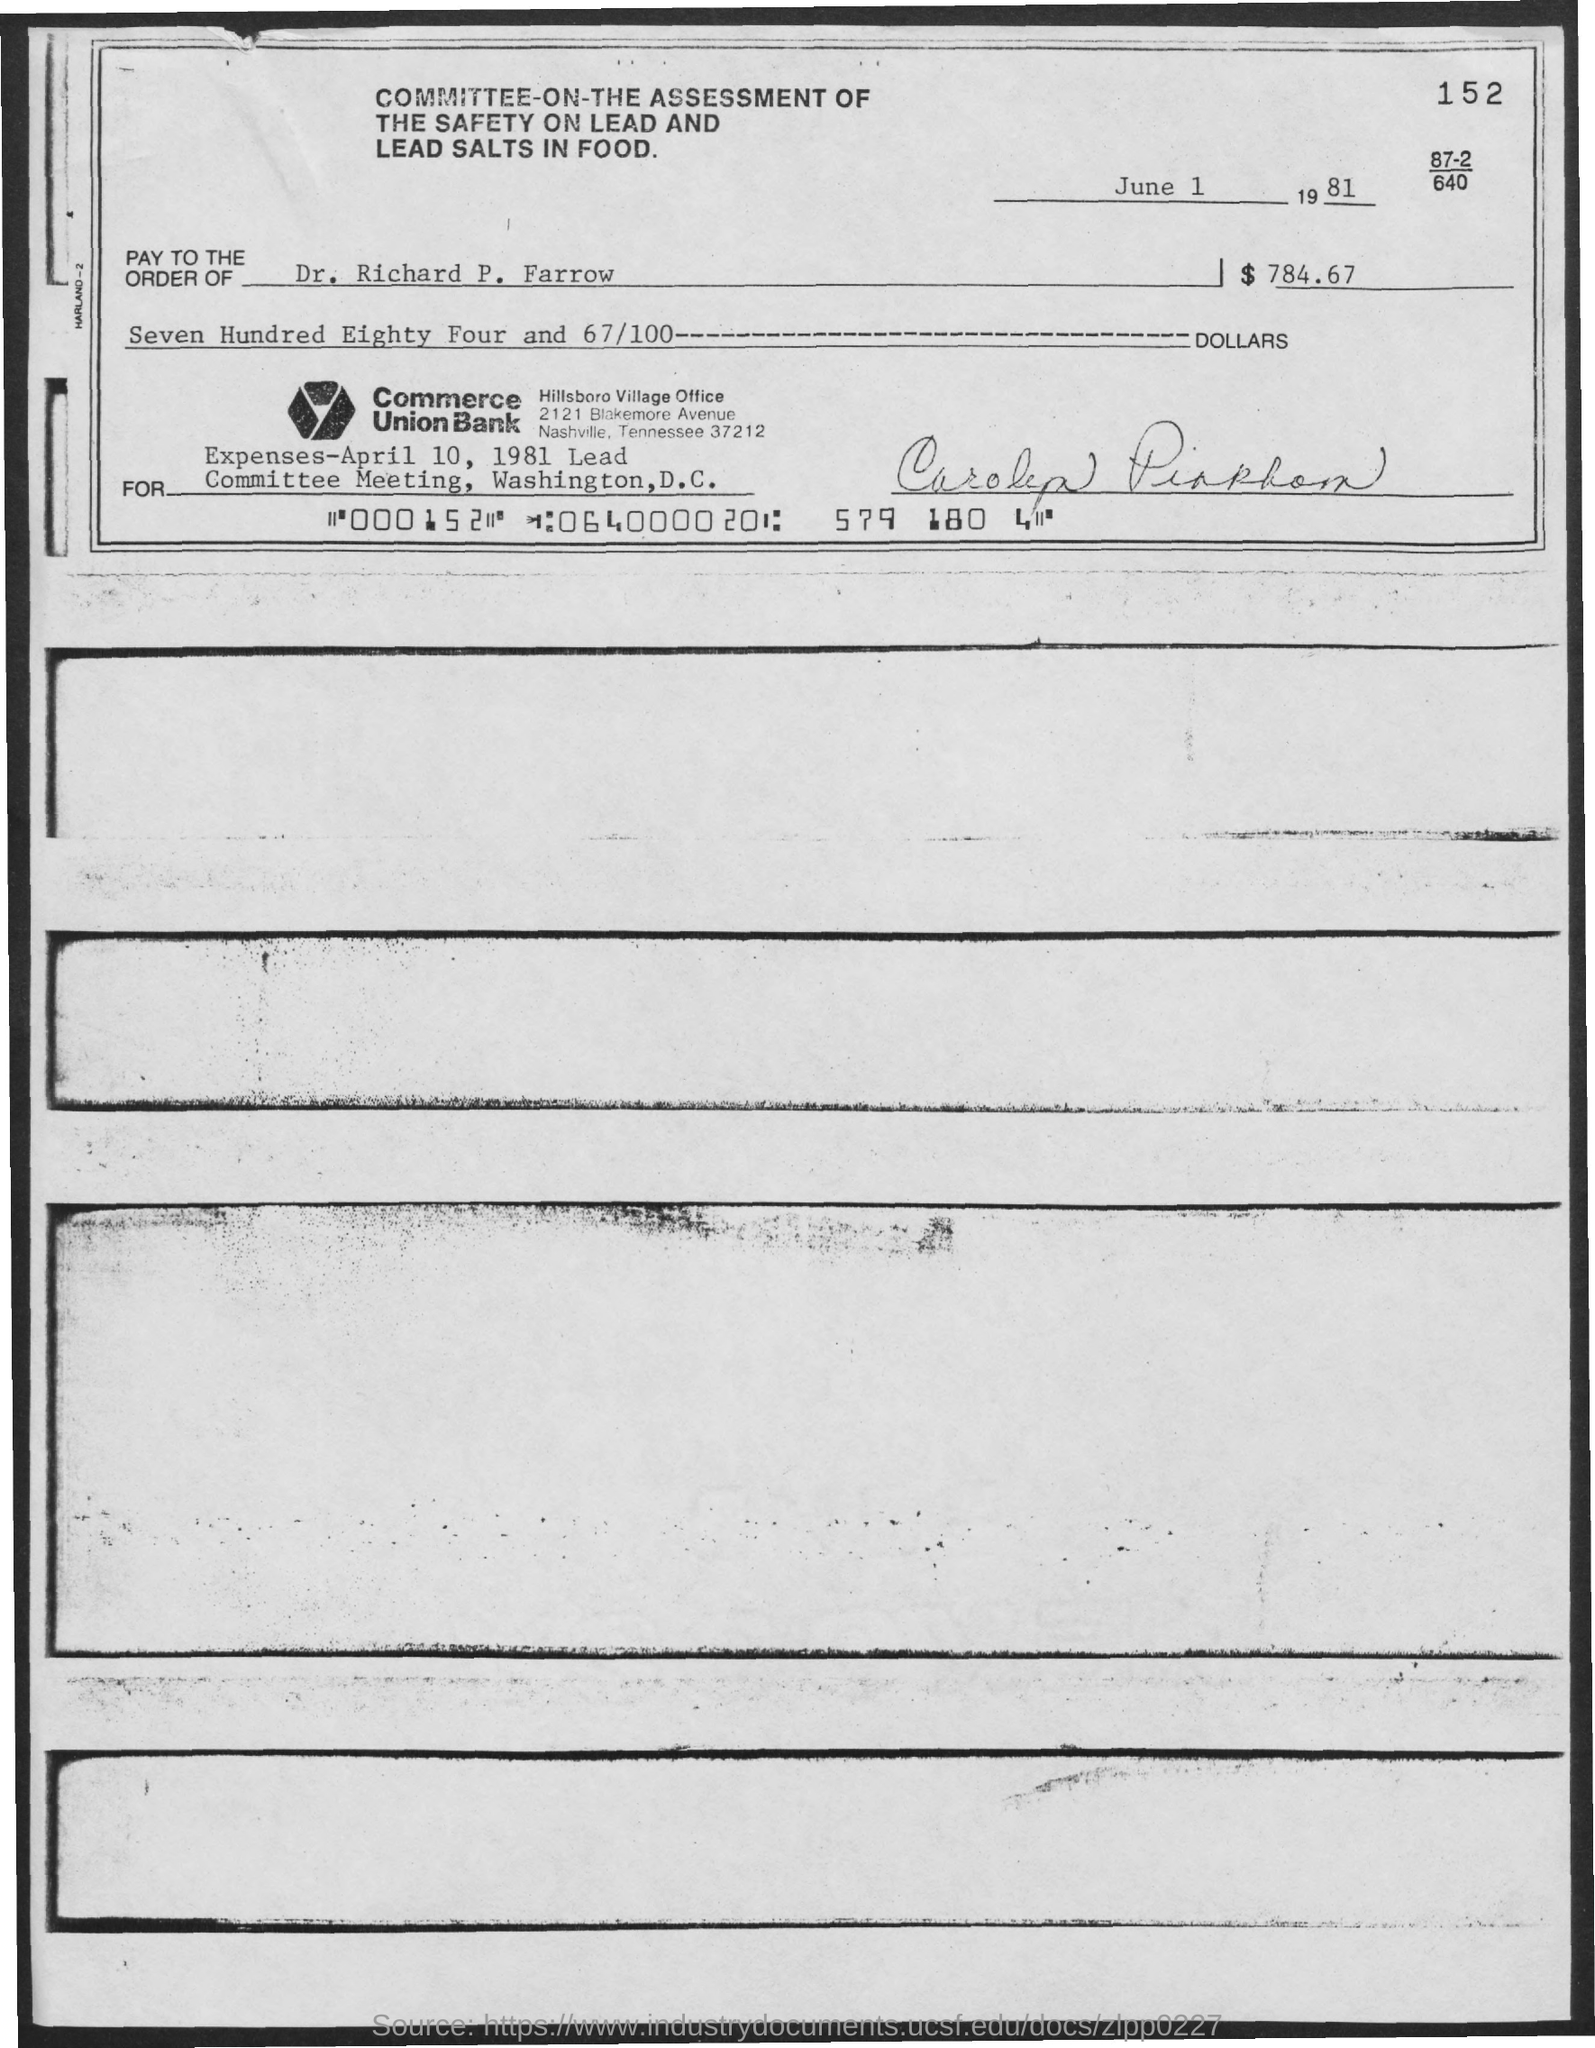What is the date mentioned at the top of the document?
Give a very brief answer. June 1 1981. What is the name of the committee?
Your answer should be compact. Committee-on-the assessment of the safety on lead and lead salts in food. What is the number written at the top right corner?
Your answer should be compact. 152. 